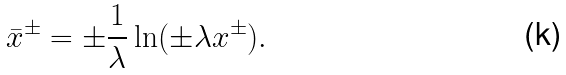Convert formula to latex. <formula><loc_0><loc_0><loc_500><loc_500>\bar { x } ^ { \pm } = \pm \frac { 1 } { \lambda } \ln ( \pm \lambda x ^ { \pm } ) .</formula> 